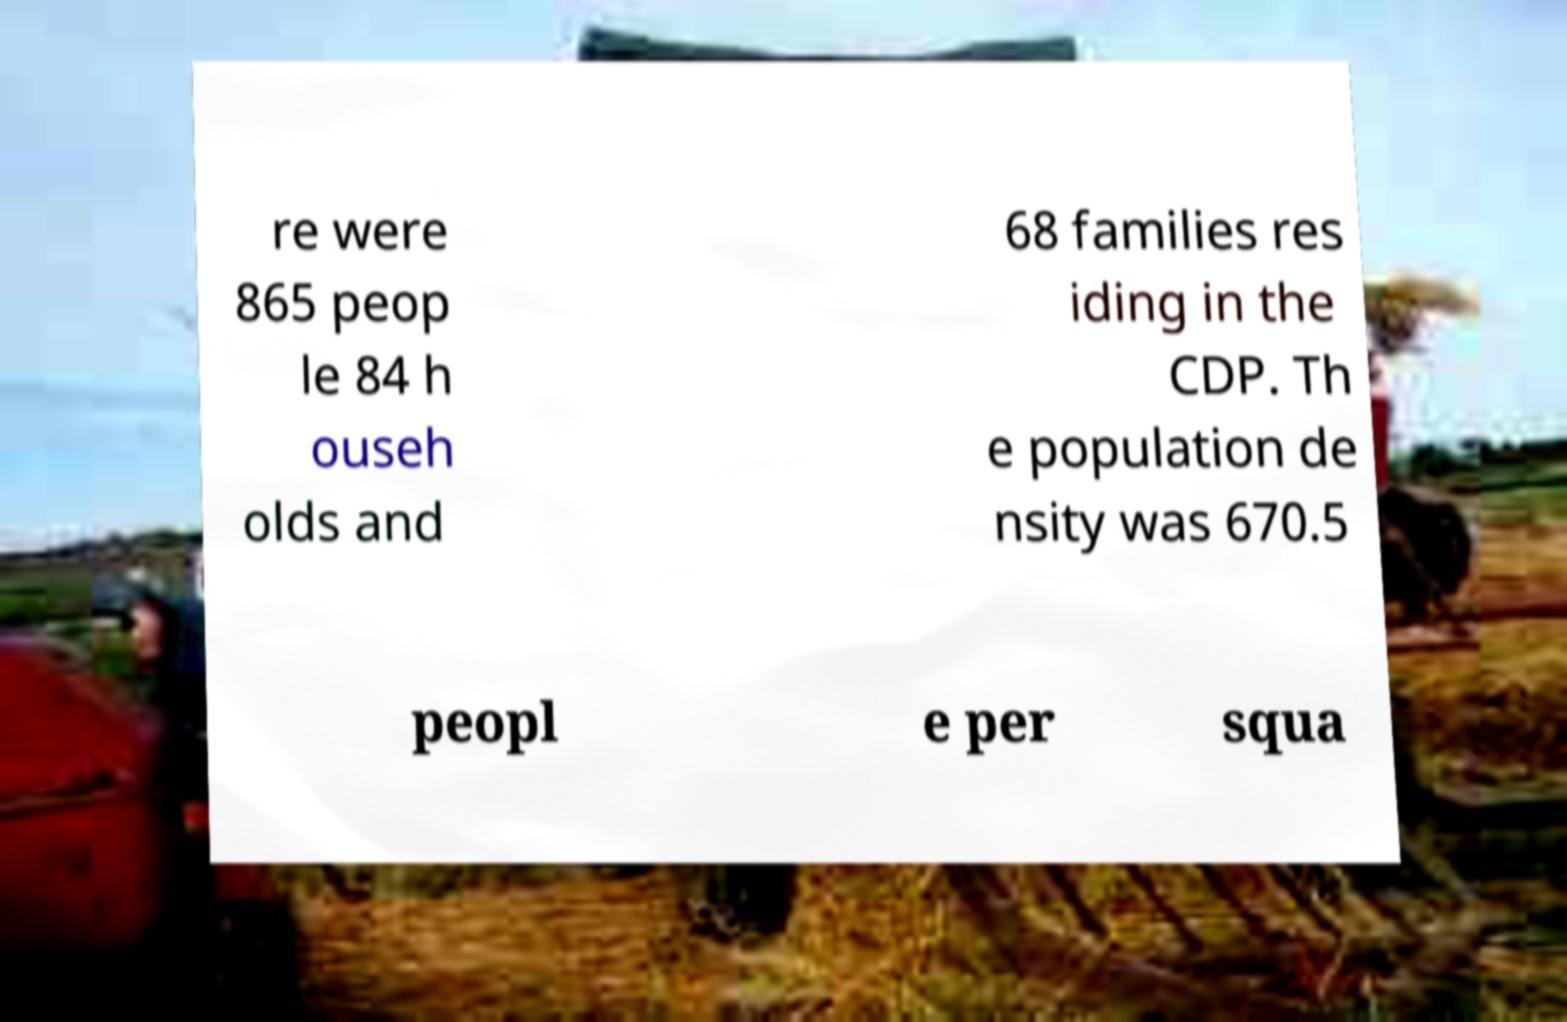There's text embedded in this image that I need extracted. Can you transcribe it verbatim? re were 865 peop le 84 h ouseh olds and 68 families res iding in the CDP. Th e population de nsity was 670.5 peopl e per squa 